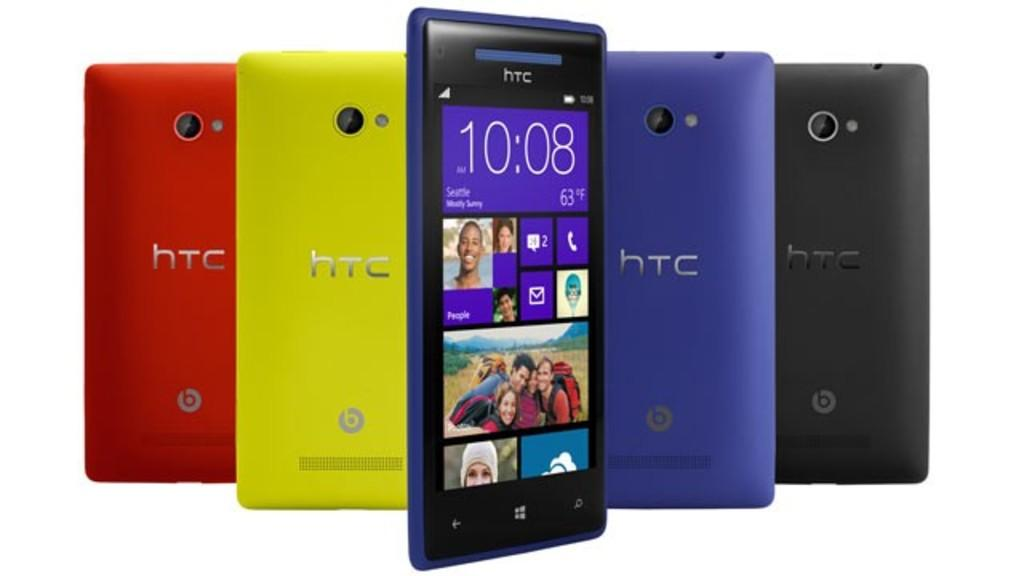<image>
Share a concise interpretation of the image provided. A row of phones that are red, yellow, blue, and black all say HTC on the back. 